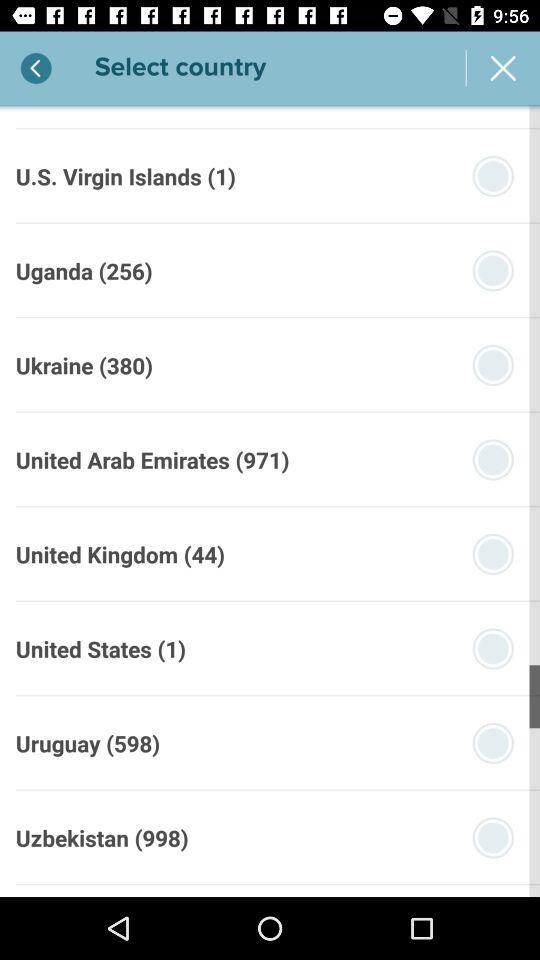Which country code is 1? The country code of the United States is 1. 